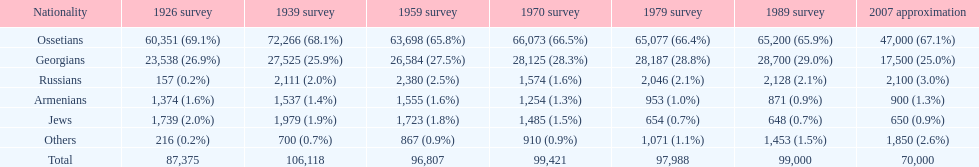What ethnicity is at the top? Ossetians. 